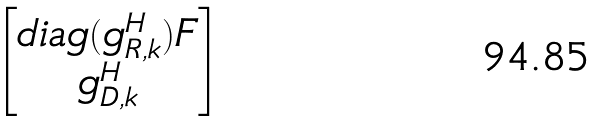<formula> <loc_0><loc_0><loc_500><loc_500>\begin{bmatrix} d i a g ( g _ { R , k } ^ { H } ) F \\ g ^ { H } _ { D , k } \end{bmatrix}</formula> 